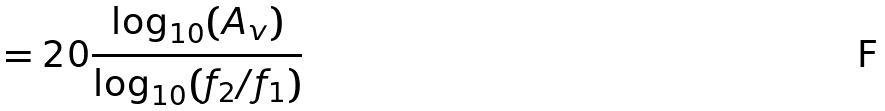Convert formula to latex. <formula><loc_0><loc_0><loc_500><loc_500>= 2 0 \frac { \log _ { 1 0 } ( A _ { v } ) } { \log _ { 1 0 } ( f _ { 2 } / f _ { 1 } ) }</formula> 